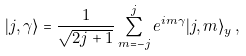Convert formula to latex. <formula><loc_0><loc_0><loc_500><loc_500>| j , \gamma \rangle = \frac { 1 } { \sqrt { 2 j + 1 } } \sum _ { m = - j } ^ { j } e ^ { i m \gamma } | j , m \rangle _ { y } \, ,</formula> 